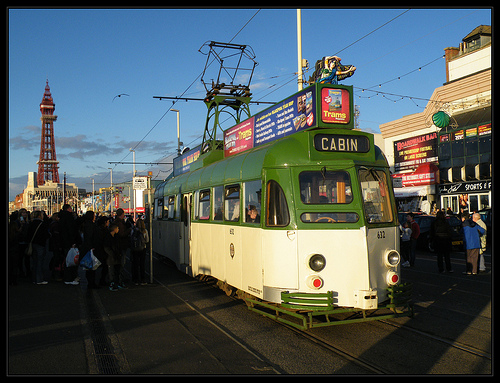<image>
Is the train behind the pole? No. The train is not behind the pole. From this viewpoint, the train appears to be positioned elsewhere in the scene. 